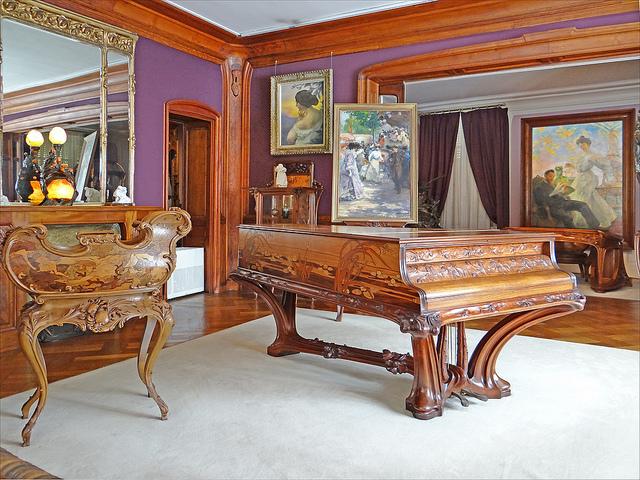What color is the rug?
Concise answer only. White. What year was that piano made?
Keep it brief. 1930. Does the piano match the room?
Short answer required. Yes. 